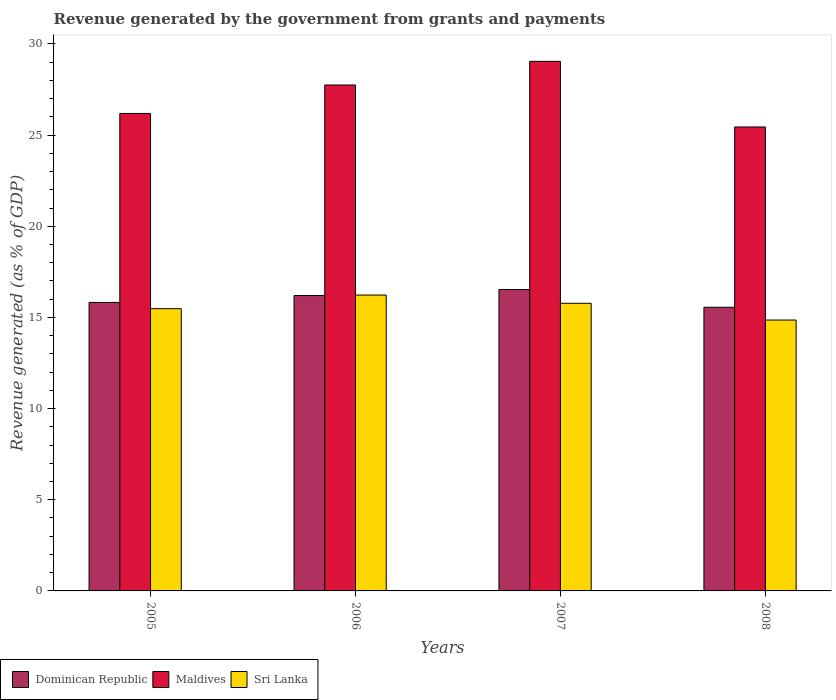How many groups of bars are there?
Provide a short and direct response. 4. Are the number of bars per tick equal to the number of legend labels?
Make the answer very short. Yes. How many bars are there on the 4th tick from the right?
Provide a short and direct response. 3. What is the label of the 3rd group of bars from the left?
Your answer should be compact. 2007. In how many cases, is the number of bars for a given year not equal to the number of legend labels?
Make the answer very short. 0. What is the revenue generated by the government in Dominican Republic in 2005?
Your answer should be compact. 15.82. Across all years, what is the maximum revenue generated by the government in Sri Lanka?
Your response must be concise. 16.23. Across all years, what is the minimum revenue generated by the government in Maldives?
Make the answer very short. 25.44. In which year was the revenue generated by the government in Sri Lanka maximum?
Make the answer very short. 2006. What is the total revenue generated by the government in Dominican Republic in the graph?
Keep it short and to the point. 64.11. What is the difference between the revenue generated by the government in Sri Lanka in 2007 and that in 2008?
Provide a short and direct response. 0.92. What is the difference between the revenue generated by the government in Dominican Republic in 2007 and the revenue generated by the government in Sri Lanka in 2006?
Keep it short and to the point. 0.3. What is the average revenue generated by the government in Sri Lanka per year?
Your answer should be very brief. 15.58. In the year 2008, what is the difference between the revenue generated by the government in Sri Lanka and revenue generated by the government in Dominican Republic?
Your answer should be compact. -0.7. In how many years, is the revenue generated by the government in Dominican Republic greater than 4 %?
Your answer should be compact. 4. What is the ratio of the revenue generated by the government in Maldives in 2007 to that in 2008?
Give a very brief answer. 1.14. Is the revenue generated by the government in Sri Lanka in 2005 less than that in 2008?
Keep it short and to the point. No. What is the difference between the highest and the second highest revenue generated by the government in Sri Lanka?
Your response must be concise. 0.45. What is the difference between the highest and the lowest revenue generated by the government in Maldives?
Offer a terse response. 3.6. Is the sum of the revenue generated by the government in Dominican Republic in 2005 and 2006 greater than the maximum revenue generated by the government in Maldives across all years?
Your response must be concise. Yes. What does the 2nd bar from the left in 2007 represents?
Offer a terse response. Maldives. What does the 2nd bar from the right in 2008 represents?
Offer a terse response. Maldives. Is it the case that in every year, the sum of the revenue generated by the government in Maldives and revenue generated by the government in Sri Lanka is greater than the revenue generated by the government in Dominican Republic?
Keep it short and to the point. Yes. How many bars are there?
Keep it short and to the point. 12. How many years are there in the graph?
Provide a short and direct response. 4. What is the difference between two consecutive major ticks on the Y-axis?
Offer a very short reply. 5. Are the values on the major ticks of Y-axis written in scientific E-notation?
Ensure brevity in your answer.  No. Does the graph contain any zero values?
Keep it short and to the point. No. Does the graph contain grids?
Keep it short and to the point. No. How are the legend labels stacked?
Provide a short and direct response. Horizontal. What is the title of the graph?
Provide a succinct answer. Revenue generated by the government from grants and payments. What is the label or title of the Y-axis?
Offer a terse response. Revenue generated (as % of GDP). What is the Revenue generated (as % of GDP) in Dominican Republic in 2005?
Your response must be concise. 15.82. What is the Revenue generated (as % of GDP) in Maldives in 2005?
Provide a succinct answer. 26.19. What is the Revenue generated (as % of GDP) in Sri Lanka in 2005?
Offer a terse response. 15.48. What is the Revenue generated (as % of GDP) in Dominican Republic in 2006?
Provide a short and direct response. 16.2. What is the Revenue generated (as % of GDP) in Maldives in 2006?
Your response must be concise. 27.75. What is the Revenue generated (as % of GDP) of Sri Lanka in 2006?
Offer a very short reply. 16.23. What is the Revenue generated (as % of GDP) of Dominican Republic in 2007?
Your answer should be compact. 16.53. What is the Revenue generated (as % of GDP) in Maldives in 2007?
Provide a short and direct response. 29.04. What is the Revenue generated (as % of GDP) of Sri Lanka in 2007?
Your response must be concise. 15.77. What is the Revenue generated (as % of GDP) of Dominican Republic in 2008?
Provide a succinct answer. 15.56. What is the Revenue generated (as % of GDP) of Maldives in 2008?
Offer a terse response. 25.44. What is the Revenue generated (as % of GDP) in Sri Lanka in 2008?
Give a very brief answer. 14.86. Across all years, what is the maximum Revenue generated (as % of GDP) of Dominican Republic?
Ensure brevity in your answer.  16.53. Across all years, what is the maximum Revenue generated (as % of GDP) in Maldives?
Give a very brief answer. 29.04. Across all years, what is the maximum Revenue generated (as % of GDP) in Sri Lanka?
Your answer should be compact. 16.23. Across all years, what is the minimum Revenue generated (as % of GDP) of Dominican Republic?
Keep it short and to the point. 15.56. Across all years, what is the minimum Revenue generated (as % of GDP) in Maldives?
Your answer should be compact. 25.44. Across all years, what is the minimum Revenue generated (as % of GDP) in Sri Lanka?
Your response must be concise. 14.86. What is the total Revenue generated (as % of GDP) in Dominican Republic in the graph?
Your answer should be compact. 64.11. What is the total Revenue generated (as % of GDP) in Maldives in the graph?
Provide a short and direct response. 108.42. What is the total Revenue generated (as % of GDP) of Sri Lanka in the graph?
Provide a short and direct response. 62.34. What is the difference between the Revenue generated (as % of GDP) in Dominican Republic in 2005 and that in 2006?
Your answer should be compact. -0.38. What is the difference between the Revenue generated (as % of GDP) of Maldives in 2005 and that in 2006?
Offer a very short reply. -1.56. What is the difference between the Revenue generated (as % of GDP) in Sri Lanka in 2005 and that in 2006?
Make the answer very short. -0.75. What is the difference between the Revenue generated (as % of GDP) in Dominican Republic in 2005 and that in 2007?
Your answer should be very brief. -0.71. What is the difference between the Revenue generated (as % of GDP) in Maldives in 2005 and that in 2007?
Ensure brevity in your answer.  -2.86. What is the difference between the Revenue generated (as % of GDP) in Sri Lanka in 2005 and that in 2007?
Make the answer very short. -0.3. What is the difference between the Revenue generated (as % of GDP) in Dominican Republic in 2005 and that in 2008?
Your answer should be compact. 0.26. What is the difference between the Revenue generated (as % of GDP) in Maldives in 2005 and that in 2008?
Your response must be concise. 0.74. What is the difference between the Revenue generated (as % of GDP) of Sri Lanka in 2005 and that in 2008?
Keep it short and to the point. 0.62. What is the difference between the Revenue generated (as % of GDP) in Dominican Republic in 2006 and that in 2007?
Keep it short and to the point. -0.33. What is the difference between the Revenue generated (as % of GDP) in Maldives in 2006 and that in 2007?
Provide a succinct answer. -1.3. What is the difference between the Revenue generated (as % of GDP) in Sri Lanka in 2006 and that in 2007?
Make the answer very short. 0.45. What is the difference between the Revenue generated (as % of GDP) in Dominican Republic in 2006 and that in 2008?
Give a very brief answer. 0.64. What is the difference between the Revenue generated (as % of GDP) in Maldives in 2006 and that in 2008?
Keep it short and to the point. 2.3. What is the difference between the Revenue generated (as % of GDP) in Sri Lanka in 2006 and that in 2008?
Offer a terse response. 1.37. What is the difference between the Revenue generated (as % of GDP) in Dominican Republic in 2007 and that in 2008?
Ensure brevity in your answer.  0.97. What is the difference between the Revenue generated (as % of GDP) in Maldives in 2007 and that in 2008?
Provide a succinct answer. 3.6. What is the difference between the Revenue generated (as % of GDP) in Sri Lanka in 2007 and that in 2008?
Provide a short and direct response. 0.92. What is the difference between the Revenue generated (as % of GDP) of Dominican Republic in 2005 and the Revenue generated (as % of GDP) of Maldives in 2006?
Provide a succinct answer. -11.92. What is the difference between the Revenue generated (as % of GDP) of Dominican Republic in 2005 and the Revenue generated (as % of GDP) of Sri Lanka in 2006?
Give a very brief answer. -0.4. What is the difference between the Revenue generated (as % of GDP) in Maldives in 2005 and the Revenue generated (as % of GDP) in Sri Lanka in 2006?
Provide a short and direct response. 9.96. What is the difference between the Revenue generated (as % of GDP) in Dominican Republic in 2005 and the Revenue generated (as % of GDP) in Maldives in 2007?
Provide a succinct answer. -13.22. What is the difference between the Revenue generated (as % of GDP) in Dominican Republic in 2005 and the Revenue generated (as % of GDP) in Sri Lanka in 2007?
Your response must be concise. 0.05. What is the difference between the Revenue generated (as % of GDP) of Maldives in 2005 and the Revenue generated (as % of GDP) of Sri Lanka in 2007?
Give a very brief answer. 10.41. What is the difference between the Revenue generated (as % of GDP) of Dominican Republic in 2005 and the Revenue generated (as % of GDP) of Maldives in 2008?
Offer a very short reply. -9.62. What is the difference between the Revenue generated (as % of GDP) of Dominican Republic in 2005 and the Revenue generated (as % of GDP) of Sri Lanka in 2008?
Give a very brief answer. 0.96. What is the difference between the Revenue generated (as % of GDP) of Maldives in 2005 and the Revenue generated (as % of GDP) of Sri Lanka in 2008?
Give a very brief answer. 11.33. What is the difference between the Revenue generated (as % of GDP) of Dominican Republic in 2006 and the Revenue generated (as % of GDP) of Maldives in 2007?
Your answer should be compact. -12.84. What is the difference between the Revenue generated (as % of GDP) in Dominican Republic in 2006 and the Revenue generated (as % of GDP) in Sri Lanka in 2007?
Keep it short and to the point. 0.43. What is the difference between the Revenue generated (as % of GDP) in Maldives in 2006 and the Revenue generated (as % of GDP) in Sri Lanka in 2007?
Offer a terse response. 11.97. What is the difference between the Revenue generated (as % of GDP) of Dominican Republic in 2006 and the Revenue generated (as % of GDP) of Maldives in 2008?
Provide a succinct answer. -9.24. What is the difference between the Revenue generated (as % of GDP) in Dominican Republic in 2006 and the Revenue generated (as % of GDP) in Sri Lanka in 2008?
Offer a terse response. 1.34. What is the difference between the Revenue generated (as % of GDP) in Maldives in 2006 and the Revenue generated (as % of GDP) in Sri Lanka in 2008?
Your answer should be very brief. 12.89. What is the difference between the Revenue generated (as % of GDP) in Dominican Republic in 2007 and the Revenue generated (as % of GDP) in Maldives in 2008?
Provide a succinct answer. -8.91. What is the difference between the Revenue generated (as % of GDP) of Dominican Republic in 2007 and the Revenue generated (as % of GDP) of Sri Lanka in 2008?
Your response must be concise. 1.67. What is the difference between the Revenue generated (as % of GDP) in Maldives in 2007 and the Revenue generated (as % of GDP) in Sri Lanka in 2008?
Your response must be concise. 14.19. What is the average Revenue generated (as % of GDP) of Dominican Republic per year?
Your response must be concise. 16.03. What is the average Revenue generated (as % of GDP) of Maldives per year?
Keep it short and to the point. 27.1. What is the average Revenue generated (as % of GDP) in Sri Lanka per year?
Offer a terse response. 15.58. In the year 2005, what is the difference between the Revenue generated (as % of GDP) in Dominican Republic and Revenue generated (as % of GDP) in Maldives?
Keep it short and to the point. -10.36. In the year 2005, what is the difference between the Revenue generated (as % of GDP) of Dominican Republic and Revenue generated (as % of GDP) of Sri Lanka?
Provide a succinct answer. 0.34. In the year 2005, what is the difference between the Revenue generated (as % of GDP) in Maldives and Revenue generated (as % of GDP) in Sri Lanka?
Keep it short and to the point. 10.71. In the year 2006, what is the difference between the Revenue generated (as % of GDP) of Dominican Republic and Revenue generated (as % of GDP) of Maldives?
Your response must be concise. -11.55. In the year 2006, what is the difference between the Revenue generated (as % of GDP) of Dominican Republic and Revenue generated (as % of GDP) of Sri Lanka?
Provide a short and direct response. -0.03. In the year 2006, what is the difference between the Revenue generated (as % of GDP) in Maldives and Revenue generated (as % of GDP) in Sri Lanka?
Provide a succinct answer. 11.52. In the year 2007, what is the difference between the Revenue generated (as % of GDP) in Dominican Republic and Revenue generated (as % of GDP) in Maldives?
Your answer should be very brief. -12.51. In the year 2007, what is the difference between the Revenue generated (as % of GDP) in Dominican Republic and Revenue generated (as % of GDP) in Sri Lanka?
Ensure brevity in your answer.  0.76. In the year 2007, what is the difference between the Revenue generated (as % of GDP) of Maldives and Revenue generated (as % of GDP) of Sri Lanka?
Keep it short and to the point. 13.27. In the year 2008, what is the difference between the Revenue generated (as % of GDP) of Dominican Republic and Revenue generated (as % of GDP) of Maldives?
Your response must be concise. -9.89. In the year 2008, what is the difference between the Revenue generated (as % of GDP) of Dominican Republic and Revenue generated (as % of GDP) of Sri Lanka?
Provide a short and direct response. 0.7. In the year 2008, what is the difference between the Revenue generated (as % of GDP) in Maldives and Revenue generated (as % of GDP) in Sri Lanka?
Offer a terse response. 10.59. What is the ratio of the Revenue generated (as % of GDP) in Dominican Republic in 2005 to that in 2006?
Ensure brevity in your answer.  0.98. What is the ratio of the Revenue generated (as % of GDP) of Maldives in 2005 to that in 2006?
Provide a succinct answer. 0.94. What is the ratio of the Revenue generated (as % of GDP) of Sri Lanka in 2005 to that in 2006?
Give a very brief answer. 0.95. What is the ratio of the Revenue generated (as % of GDP) in Dominican Republic in 2005 to that in 2007?
Your response must be concise. 0.96. What is the ratio of the Revenue generated (as % of GDP) of Maldives in 2005 to that in 2007?
Make the answer very short. 0.9. What is the ratio of the Revenue generated (as % of GDP) in Sri Lanka in 2005 to that in 2007?
Make the answer very short. 0.98. What is the ratio of the Revenue generated (as % of GDP) in Dominican Republic in 2005 to that in 2008?
Provide a short and direct response. 1.02. What is the ratio of the Revenue generated (as % of GDP) of Maldives in 2005 to that in 2008?
Your answer should be compact. 1.03. What is the ratio of the Revenue generated (as % of GDP) in Sri Lanka in 2005 to that in 2008?
Ensure brevity in your answer.  1.04. What is the ratio of the Revenue generated (as % of GDP) of Dominican Republic in 2006 to that in 2007?
Keep it short and to the point. 0.98. What is the ratio of the Revenue generated (as % of GDP) in Maldives in 2006 to that in 2007?
Offer a very short reply. 0.96. What is the ratio of the Revenue generated (as % of GDP) in Sri Lanka in 2006 to that in 2007?
Give a very brief answer. 1.03. What is the ratio of the Revenue generated (as % of GDP) of Dominican Republic in 2006 to that in 2008?
Make the answer very short. 1.04. What is the ratio of the Revenue generated (as % of GDP) in Maldives in 2006 to that in 2008?
Ensure brevity in your answer.  1.09. What is the ratio of the Revenue generated (as % of GDP) in Sri Lanka in 2006 to that in 2008?
Provide a succinct answer. 1.09. What is the ratio of the Revenue generated (as % of GDP) in Dominican Republic in 2007 to that in 2008?
Provide a succinct answer. 1.06. What is the ratio of the Revenue generated (as % of GDP) of Maldives in 2007 to that in 2008?
Your response must be concise. 1.14. What is the ratio of the Revenue generated (as % of GDP) of Sri Lanka in 2007 to that in 2008?
Offer a very short reply. 1.06. What is the difference between the highest and the second highest Revenue generated (as % of GDP) of Dominican Republic?
Your answer should be compact. 0.33. What is the difference between the highest and the second highest Revenue generated (as % of GDP) in Maldives?
Keep it short and to the point. 1.3. What is the difference between the highest and the second highest Revenue generated (as % of GDP) of Sri Lanka?
Give a very brief answer. 0.45. What is the difference between the highest and the lowest Revenue generated (as % of GDP) of Dominican Republic?
Give a very brief answer. 0.97. What is the difference between the highest and the lowest Revenue generated (as % of GDP) in Maldives?
Keep it short and to the point. 3.6. What is the difference between the highest and the lowest Revenue generated (as % of GDP) of Sri Lanka?
Make the answer very short. 1.37. 